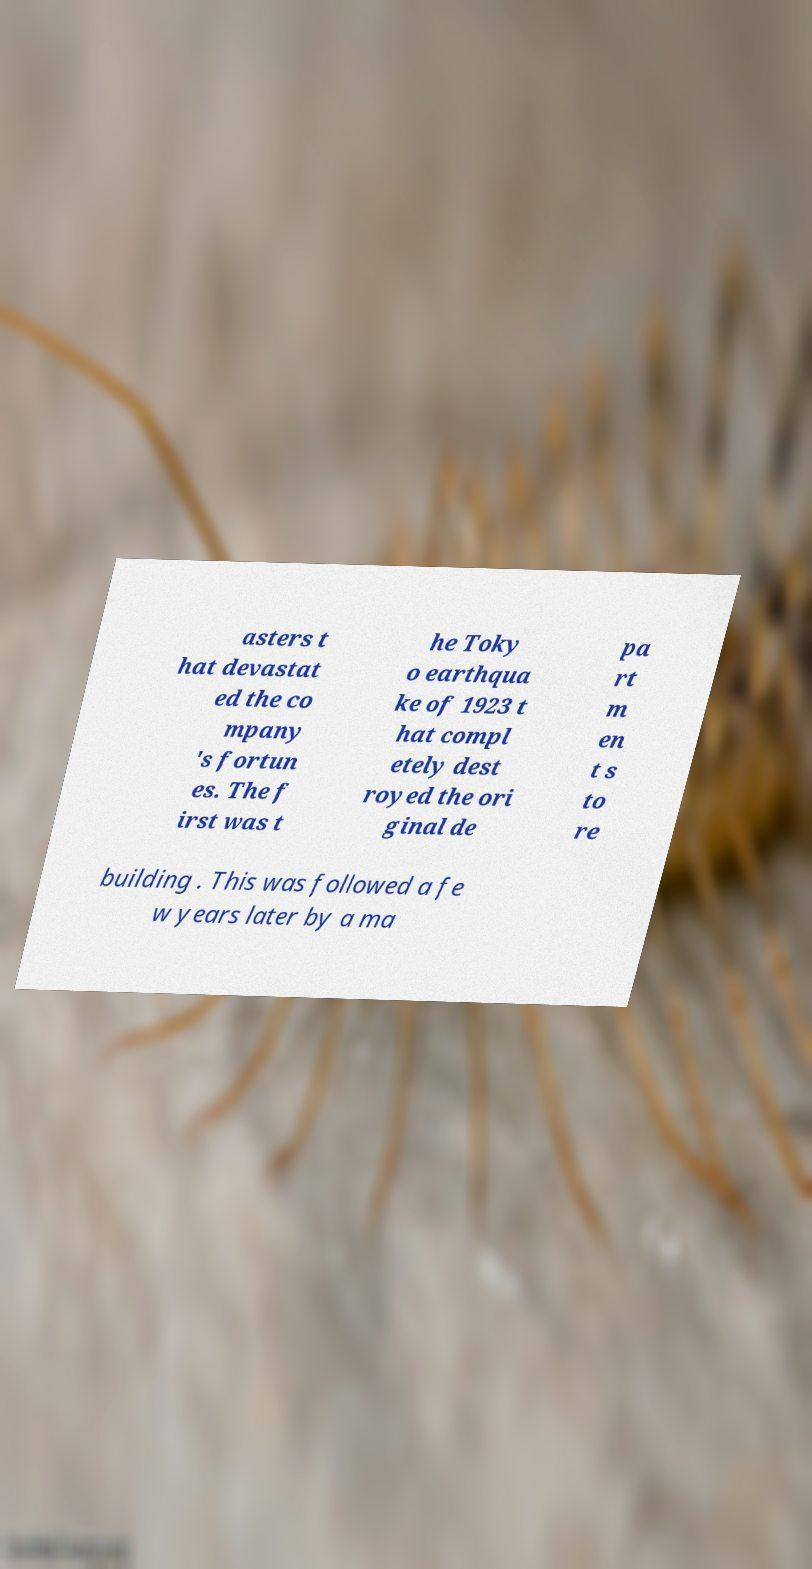Can you read and provide the text displayed in the image?This photo seems to have some interesting text. Can you extract and type it out for me? asters t hat devastat ed the co mpany 's fortun es. The f irst was t he Toky o earthqua ke of 1923 t hat compl etely dest royed the ori ginal de pa rt m en t s to re building . This was followed a fe w years later by a ma 